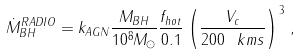<formula> <loc_0><loc_0><loc_500><loc_500>\dot { M } _ { B H } ^ { R A D I O } = k _ { A G N } \frac { M _ { B H } } { 1 0 ^ { 8 } M _ { \odot } } \frac { f _ { h o t } } { 0 . 1 } \left ( \frac { V _ { c } } { 2 0 0 \, \ k m s } \right ) ^ { 3 } \, ,</formula> 